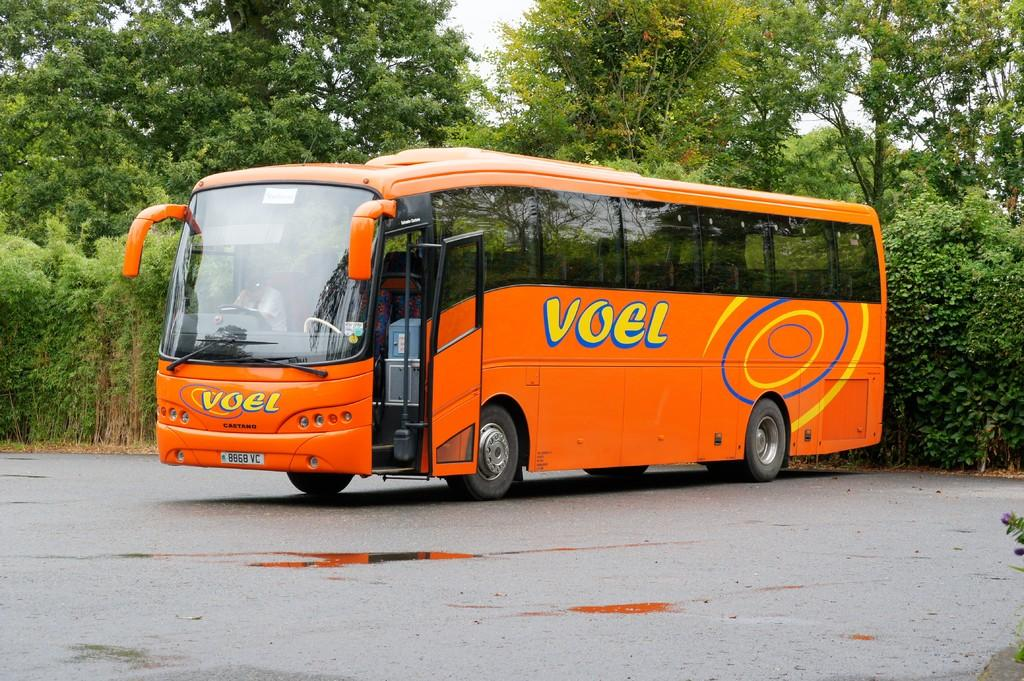What is located at the bottom of the image? There is a road at the bottom of the image. What can be seen in the middle of the image? There is a bus in the middle of the image. What type of vegetation is in the background of the image? There are trees in the background of the image. What is visible in the background of the image? The sky is visible in the background of the image. What type of alarm can be heard going off in the image? There is no alarm present in the image, and therefore no sound can be heard. What kind of rod is being used by the bus driver in the image? There is no rod visible in the image, and the bus driver's actions are not described. 